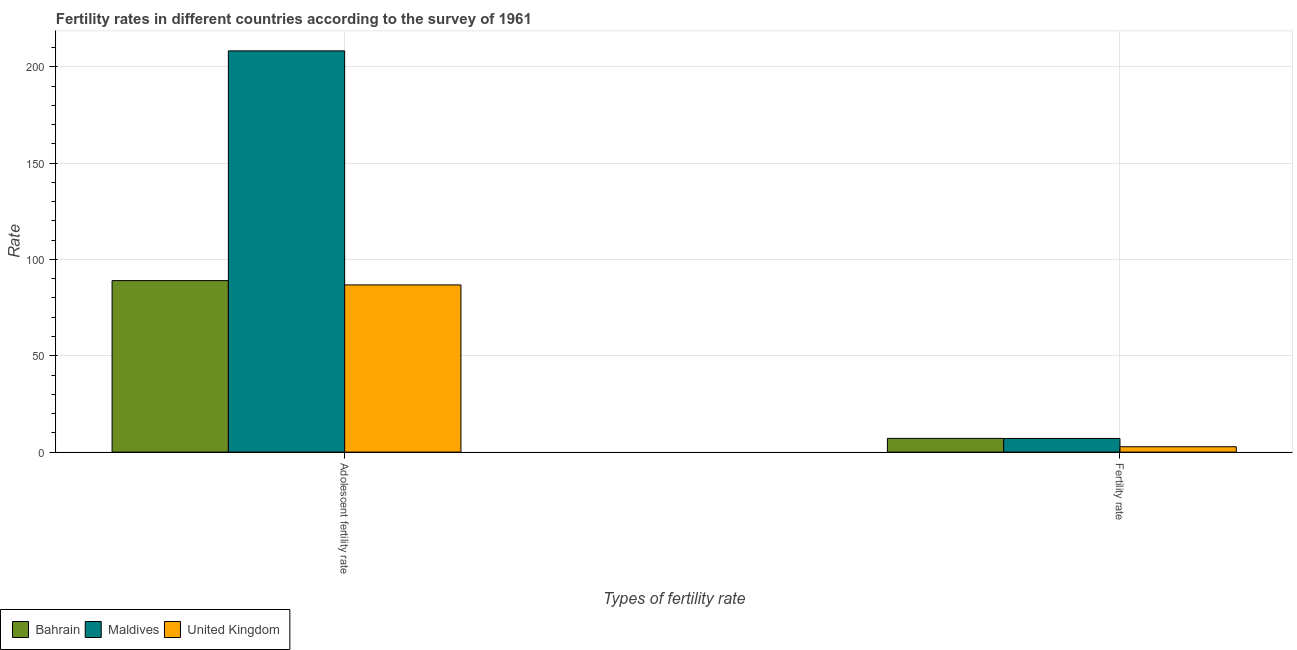Are the number of bars per tick equal to the number of legend labels?
Give a very brief answer. Yes. Are the number of bars on each tick of the X-axis equal?
Give a very brief answer. Yes. How many bars are there on the 1st tick from the left?
Make the answer very short. 3. What is the label of the 1st group of bars from the left?
Keep it short and to the point. Adolescent fertility rate. What is the fertility rate in United Kingdom?
Provide a short and direct response. 2.78. Across all countries, what is the maximum adolescent fertility rate?
Give a very brief answer. 208.24. Across all countries, what is the minimum adolescent fertility rate?
Offer a very short reply. 86.76. In which country was the adolescent fertility rate maximum?
Offer a very short reply. Maldives. In which country was the adolescent fertility rate minimum?
Give a very brief answer. United Kingdom. What is the total fertility rate in the graph?
Your answer should be compact. 16.99. What is the difference between the fertility rate in Bahrain and that in United Kingdom?
Your answer should be compact. 4.35. What is the difference between the fertility rate in Maldives and the adolescent fertility rate in Bahrain?
Your response must be concise. -81.93. What is the average fertility rate per country?
Provide a short and direct response. 5.66. What is the difference between the adolescent fertility rate and fertility rate in Maldives?
Provide a short and direct response. 201.16. What is the ratio of the adolescent fertility rate in Maldives to that in United Kingdom?
Provide a short and direct response. 2.4. What does the 2nd bar from the left in Fertility rate represents?
Your response must be concise. Maldives. What does the 1st bar from the right in Fertility rate represents?
Keep it short and to the point. United Kingdom. Does the graph contain any zero values?
Give a very brief answer. No. Does the graph contain grids?
Give a very brief answer. Yes. Where does the legend appear in the graph?
Offer a very short reply. Bottom left. What is the title of the graph?
Offer a terse response. Fertility rates in different countries according to the survey of 1961. What is the label or title of the X-axis?
Make the answer very short. Types of fertility rate. What is the label or title of the Y-axis?
Keep it short and to the point. Rate. What is the Rate in Bahrain in Adolescent fertility rate?
Your answer should be very brief. 89. What is the Rate of Maldives in Adolescent fertility rate?
Keep it short and to the point. 208.24. What is the Rate of United Kingdom in Adolescent fertility rate?
Give a very brief answer. 86.76. What is the Rate of Bahrain in Fertility rate?
Your answer should be very brief. 7.13. What is the Rate of Maldives in Fertility rate?
Give a very brief answer. 7.08. What is the Rate in United Kingdom in Fertility rate?
Make the answer very short. 2.78. Across all Types of fertility rate, what is the maximum Rate in Bahrain?
Ensure brevity in your answer.  89. Across all Types of fertility rate, what is the maximum Rate of Maldives?
Make the answer very short. 208.24. Across all Types of fertility rate, what is the maximum Rate of United Kingdom?
Your answer should be very brief. 86.76. Across all Types of fertility rate, what is the minimum Rate in Bahrain?
Your answer should be compact. 7.13. Across all Types of fertility rate, what is the minimum Rate in Maldives?
Give a very brief answer. 7.08. Across all Types of fertility rate, what is the minimum Rate in United Kingdom?
Give a very brief answer. 2.78. What is the total Rate in Bahrain in the graph?
Your answer should be compact. 96.14. What is the total Rate of Maldives in the graph?
Your answer should be very brief. 215.31. What is the total Rate in United Kingdom in the graph?
Give a very brief answer. 89.54. What is the difference between the Rate in Bahrain in Adolescent fertility rate and that in Fertility rate?
Make the answer very short. 81.87. What is the difference between the Rate in Maldives in Adolescent fertility rate and that in Fertility rate?
Provide a succinct answer. 201.16. What is the difference between the Rate of United Kingdom in Adolescent fertility rate and that in Fertility rate?
Keep it short and to the point. 83.98. What is the difference between the Rate in Bahrain in Adolescent fertility rate and the Rate in Maldives in Fertility rate?
Keep it short and to the point. 81.93. What is the difference between the Rate of Bahrain in Adolescent fertility rate and the Rate of United Kingdom in Fertility rate?
Provide a short and direct response. 86.22. What is the difference between the Rate of Maldives in Adolescent fertility rate and the Rate of United Kingdom in Fertility rate?
Your answer should be very brief. 205.46. What is the average Rate in Bahrain per Types of fertility rate?
Your answer should be very brief. 48.07. What is the average Rate in Maldives per Types of fertility rate?
Provide a succinct answer. 107.66. What is the average Rate in United Kingdom per Types of fertility rate?
Offer a very short reply. 44.77. What is the difference between the Rate in Bahrain and Rate in Maldives in Adolescent fertility rate?
Make the answer very short. -119.23. What is the difference between the Rate in Bahrain and Rate in United Kingdom in Adolescent fertility rate?
Give a very brief answer. 2.24. What is the difference between the Rate of Maldives and Rate of United Kingdom in Adolescent fertility rate?
Make the answer very short. 121.48. What is the difference between the Rate in Bahrain and Rate in Maldives in Fertility rate?
Provide a succinct answer. 0.06. What is the difference between the Rate in Bahrain and Rate in United Kingdom in Fertility rate?
Keep it short and to the point. 4.35. What is the difference between the Rate in Maldives and Rate in United Kingdom in Fertility rate?
Give a very brief answer. 4.29. What is the ratio of the Rate of Bahrain in Adolescent fertility rate to that in Fertility rate?
Offer a very short reply. 12.48. What is the ratio of the Rate of Maldives in Adolescent fertility rate to that in Fertility rate?
Provide a short and direct response. 29.43. What is the ratio of the Rate of United Kingdom in Adolescent fertility rate to that in Fertility rate?
Provide a succinct answer. 31.21. What is the difference between the highest and the second highest Rate in Bahrain?
Provide a succinct answer. 81.87. What is the difference between the highest and the second highest Rate of Maldives?
Make the answer very short. 201.16. What is the difference between the highest and the second highest Rate of United Kingdom?
Your response must be concise. 83.98. What is the difference between the highest and the lowest Rate of Bahrain?
Your answer should be compact. 81.87. What is the difference between the highest and the lowest Rate of Maldives?
Ensure brevity in your answer.  201.16. What is the difference between the highest and the lowest Rate in United Kingdom?
Ensure brevity in your answer.  83.98. 